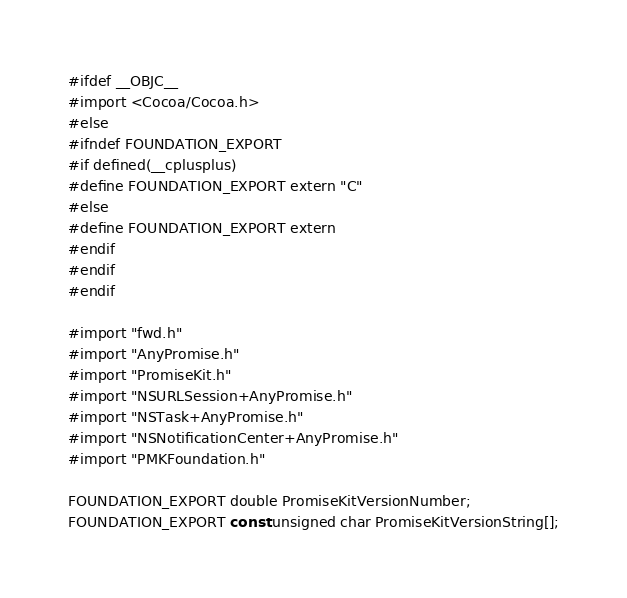Convert code to text. <code><loc_0><loc_0><loc_500><loc_500><_C_>#ifdef __OBJC__
#import <Cocoa/Cocoa.h>
#else
#ifndef FOUNDATION_EXPORT
#if defined(__cplusplus)
#define FOUNDATION_EXPORT extern "C"
#else
#define FOUNDATION_EXPORT extern
#endif
#endif
#endif

#import "fwd.h"
#import "AnyPromise.h"
#import "PromiseKit.h"
#import "NSURLSession+AnyPromise.h"
#import "NSTask+AnyPromise.h"
#import "NSNotificationCenter+AnyPromise.h"
#import "PMKFoundation.h"

FOUNDATION_EXPORT double PromiseKitVersionNumber;
FOUNDATION_EXPORT const unsigned char PromiseKitVersionString[];

</code> 